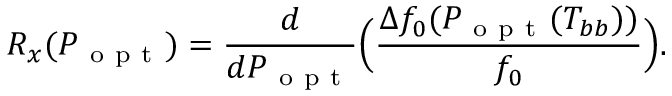Convert formula to latex. <formula><loc_0><loc_0><loc_500><loc_500>R _ { x } ( P _ { o p t } ) = \frac { d } { d P _ { o p t } } \left ( \frac { \Delta f _ { 0 } ( P _ { o p t } ( T _ { b b } ) ) } { f _ { 0 } } \right ) .</formula> 